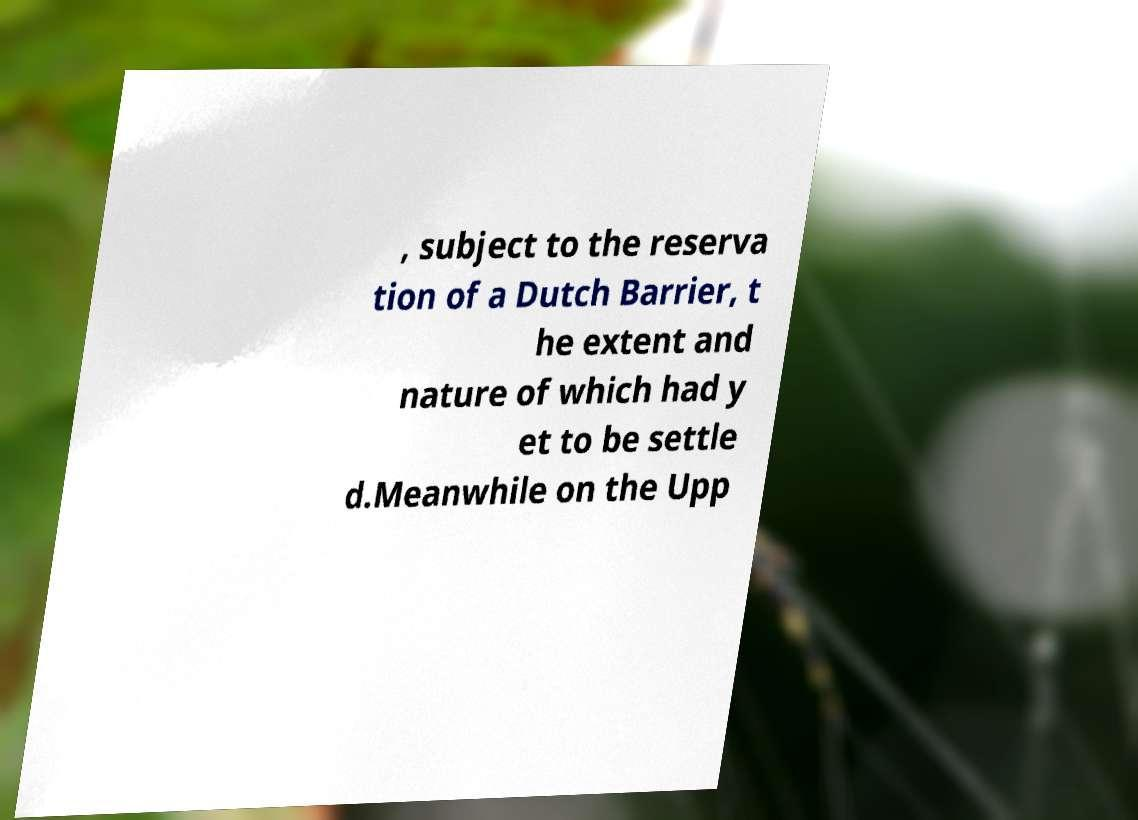What messages or text are displayed in this image? I need them in a readable, typed format. , subject to the reserva tion of a Dutch Barrier, t he extent and nature of which had y et to be settle d.Meanwhile on the Upp 